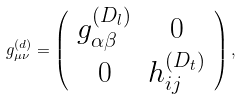<formula> <loc_0><loc_0><loc_500><loc_500>g _ { \mu \nu } ^ { ( d ) } = \left ( \begin{array} { c c } { { g _ { \alpha \beta } ^ { ( D _ { l } ) } } } & { 0 } \\ { 0 } & { { h _ { i j } ^ { ( D _ { t } ) } } } \end{array} \right ) ,</formula> 